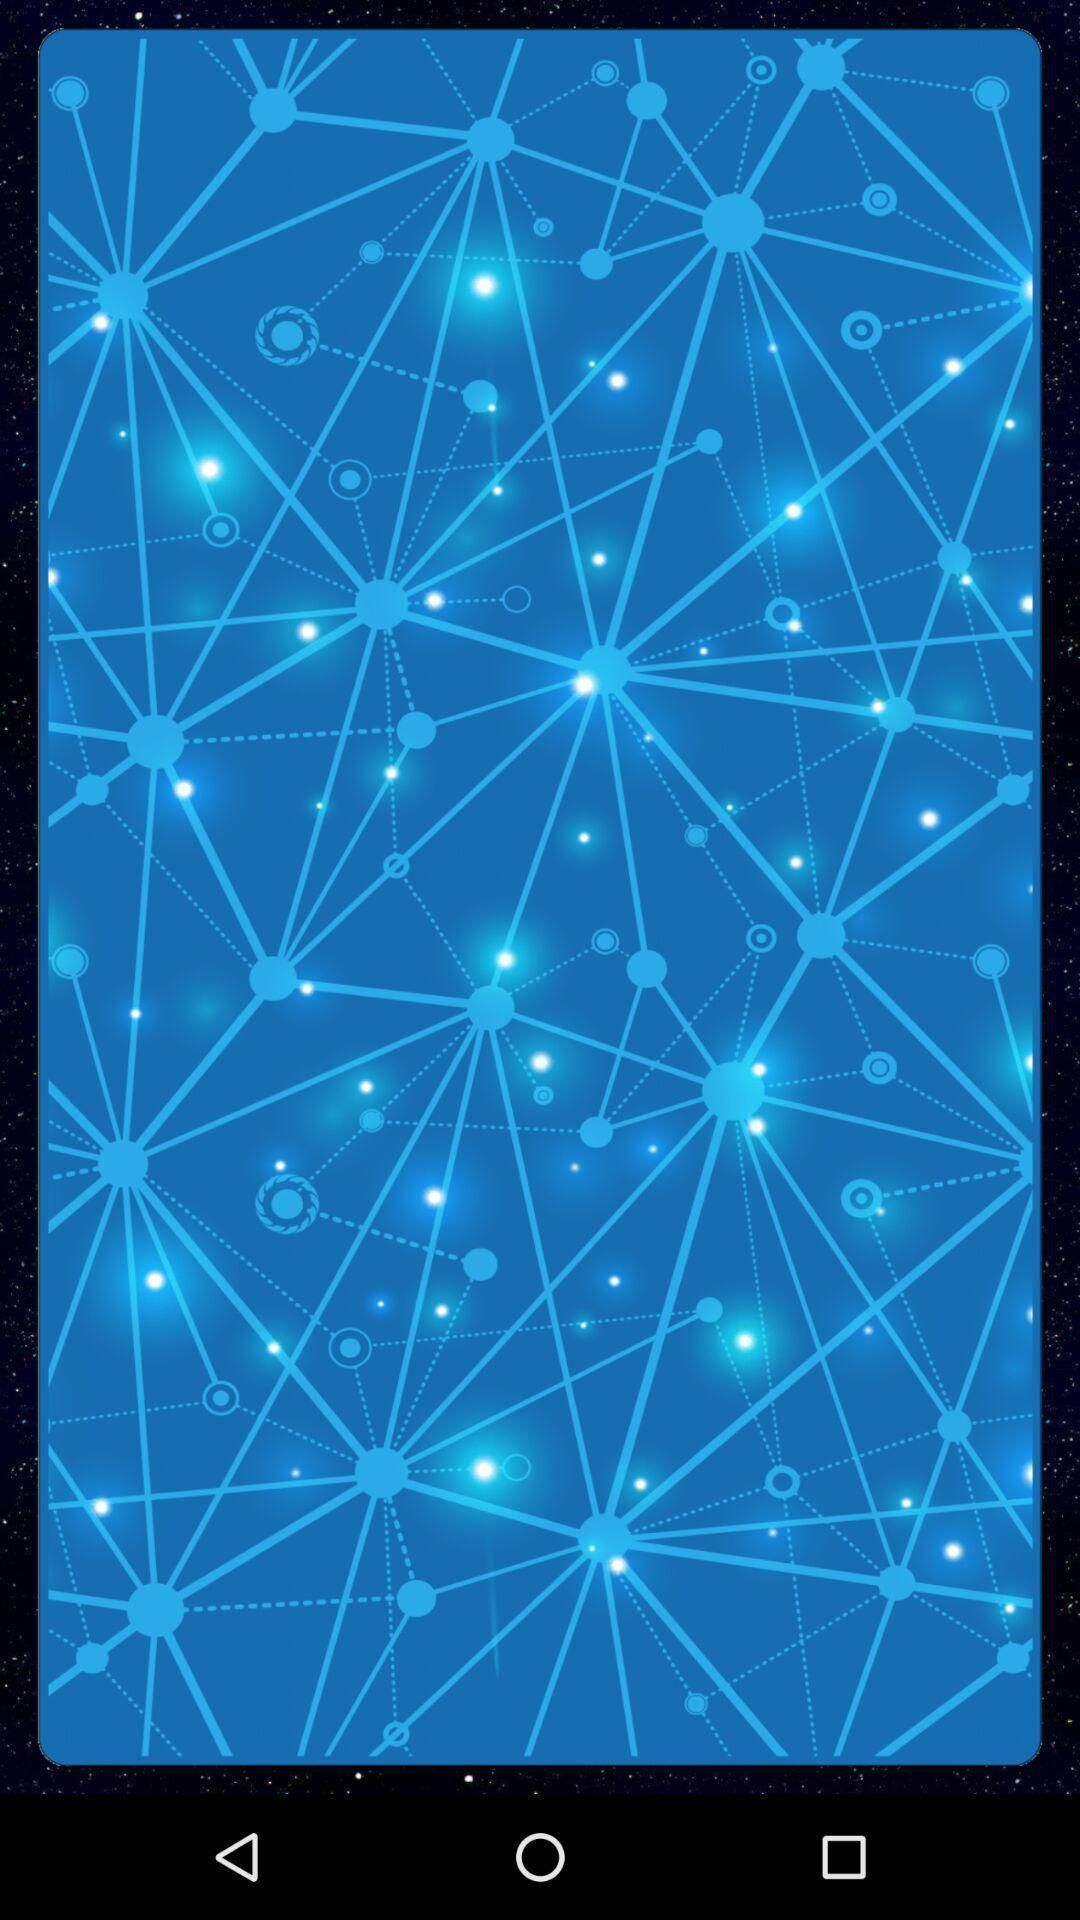Explain what's happening in this screen capture. Screen showing home page of fortune teller app. 